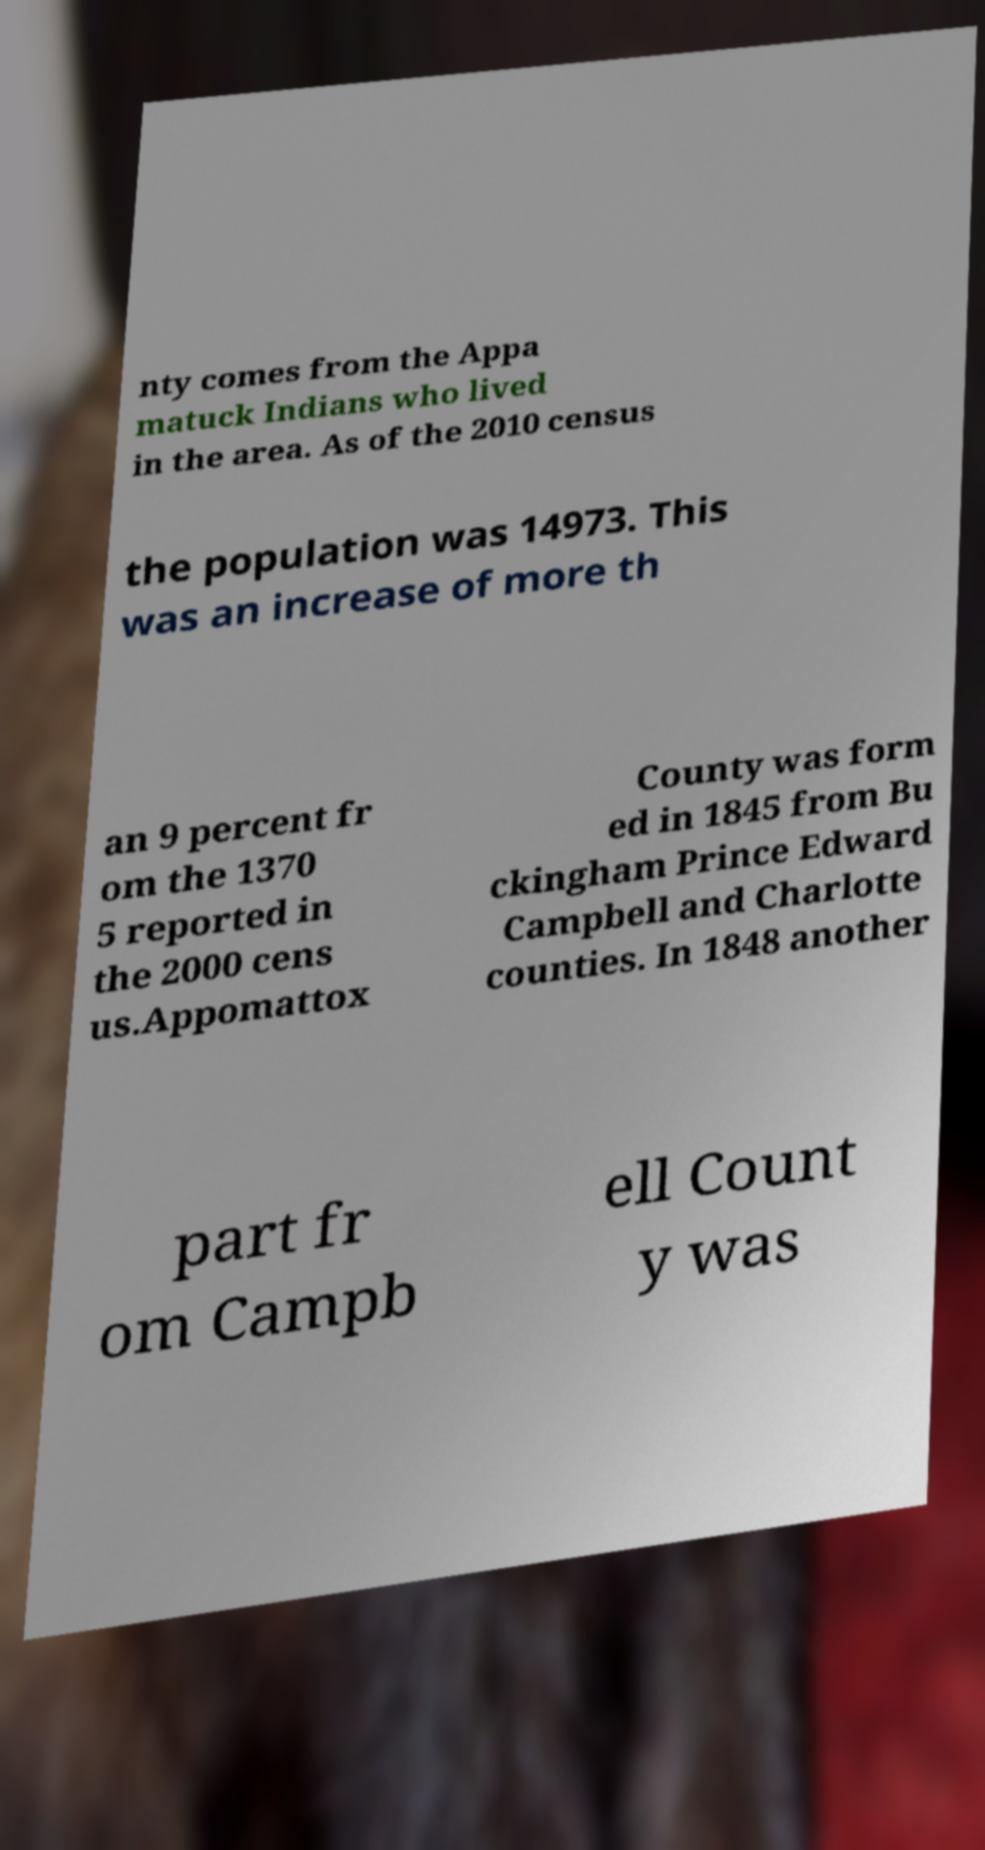Please read and relay the text visible in this image. What does it say? nty comes from the Appa matuck Indians who lived in the area. As of the 2010 census the population was 14973. This was an increase of more th an 9 percent fr om the 1370 5 reported in the 2000 cens us.Appomattox County was form ed in 1845 from Bu ckingham Prince Edward Campbell and Charlotte counties. In 1848 another part fr om Campb ell Count y was 